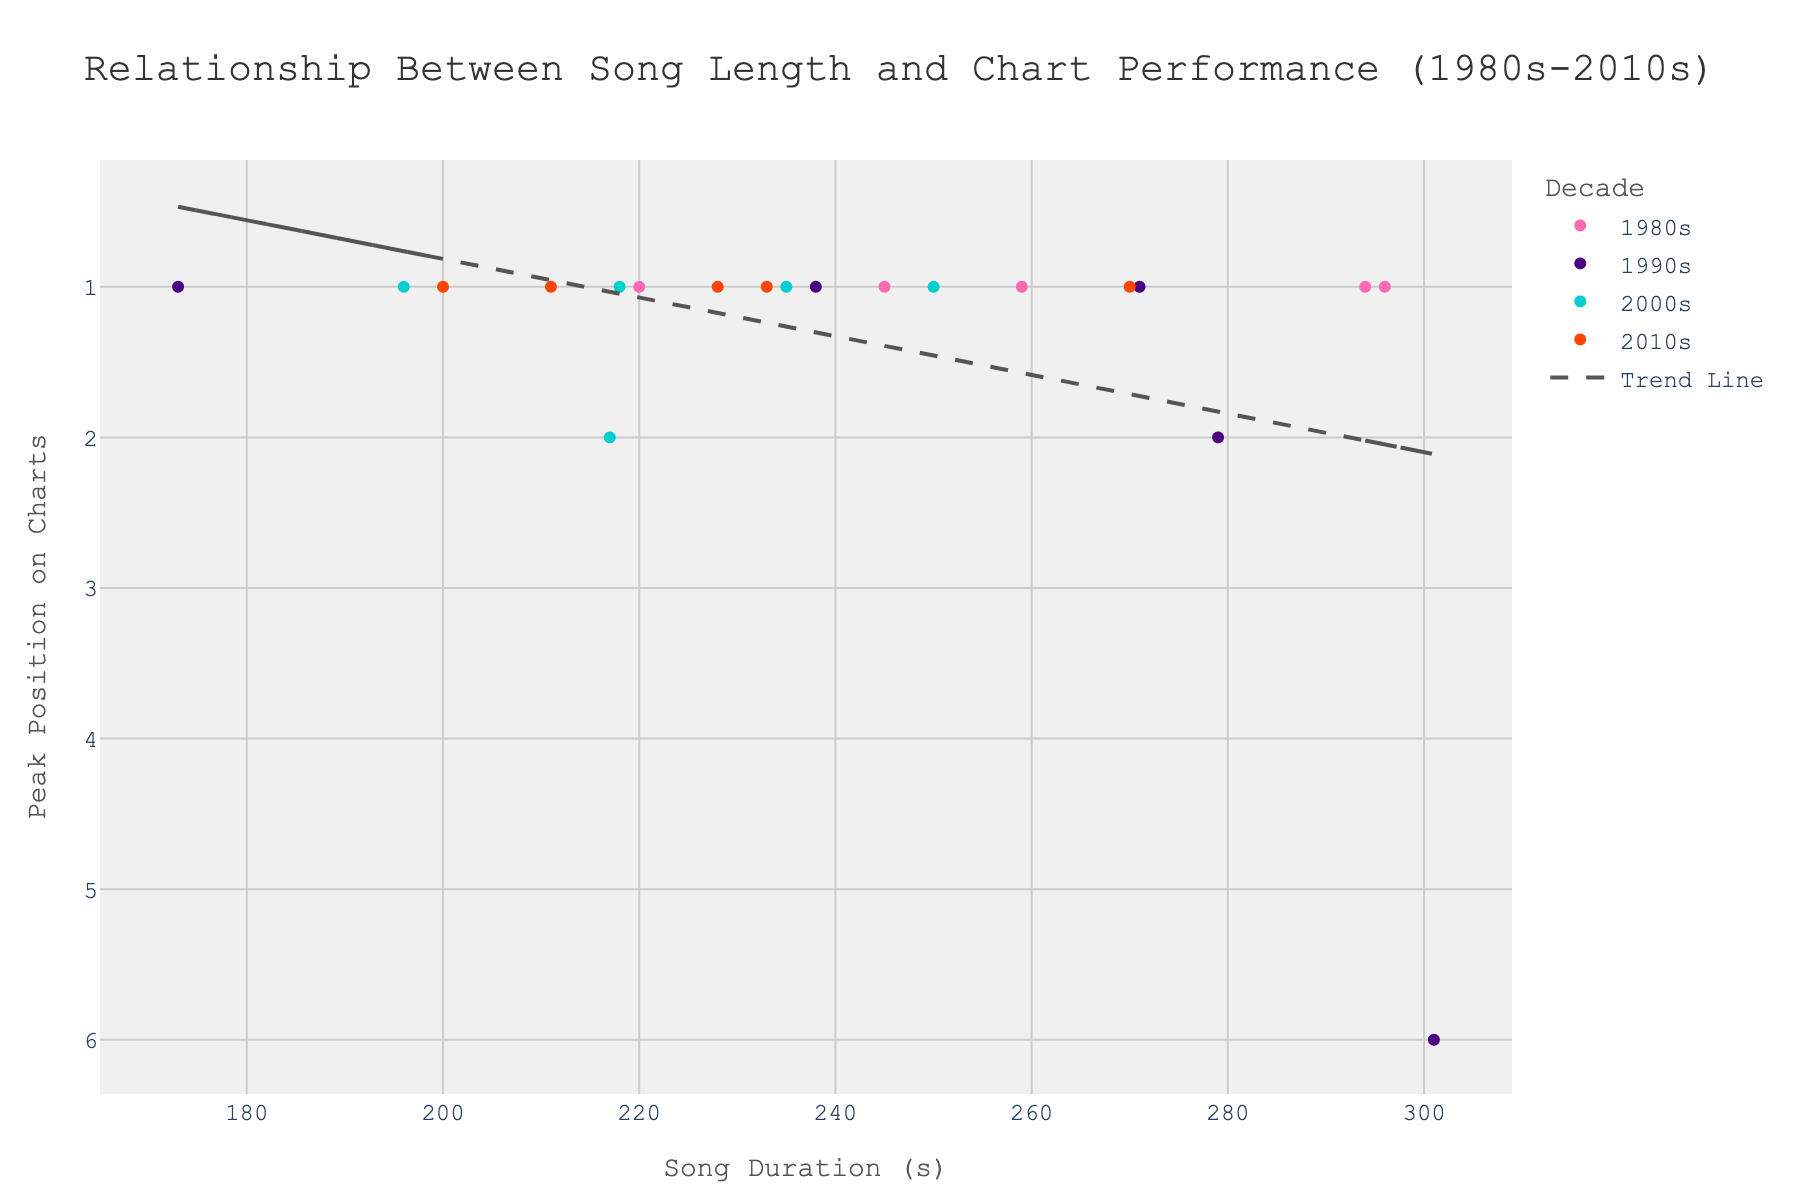What is the title of the scatter plot? Look at the top of the scatter plot where the title is prominently displayed.
Answer: Relationship Between Song Length and Chart Performance (1980s-2010s) How many song data points are there from the 2000s? Look at the color legend and identify the color representing the 2000s (Dark Turquoise). Then count the number of data points in that color.
Answer: 5 Which decade has the most songs that reached peak position 1? Observe the y-axis values and count the number of 1 positions for each decade based on the color representation from the legend.
Answer: 2010s What is the shortest song duration among top charting songs? Look at the songs on the x-axis with the smallest value.
Answer: 173 seconds What is the overall trend between song length and peak chart position? Observe the direction and slope of the trend line added to the scatter plot.
Answer: As song length increases, peak chart performance tends to decrease slightly Which song had the longest duration, and what was its peak chart position? Identify the data point furthest to the right on the x-axis, then check its peak chart position on the y-axis.
Answer: "Smells Like Teen Spirit", Peak Position 6 How does the average song length of the 1980s compare to the 2000s? Calculate the average (mean) song length for each decade by summing up their durations and dividing by the number of songs, then compare the two averages.
Answer: The average song length in the 1980s is longer Did any songs in the 1990s reach a peak position other than 1? Look at the data points in the color representing the 1990s and check if any of them are not at the y-value 1.
Answer: Yes Which two songs from different decades have the same peak chart position and almost the same song length? Identify matching y-axis values for peaks and then compare their close x-axis values.
Answer: "Eye of the Tiger" (1980s) and "Yeah!" (2000s) Is there any decade where all listed songs reached peak position 1? Check each decade’s data points to see if they all rest at y-value 1.
Answer: No 